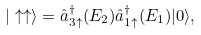<formula> <loc_0><loc_0><loc_500><loc_500>| \uparrow \uparrow \rangle = \hat { a } ^ { \dagger } _ { 3 \uparrow } ( E _ { 2 } ) \hat { a } ^ { \dagger } _ { 1 \uparrow } ( E _ { 1 } ) | 0 \rangle ,</formula> 